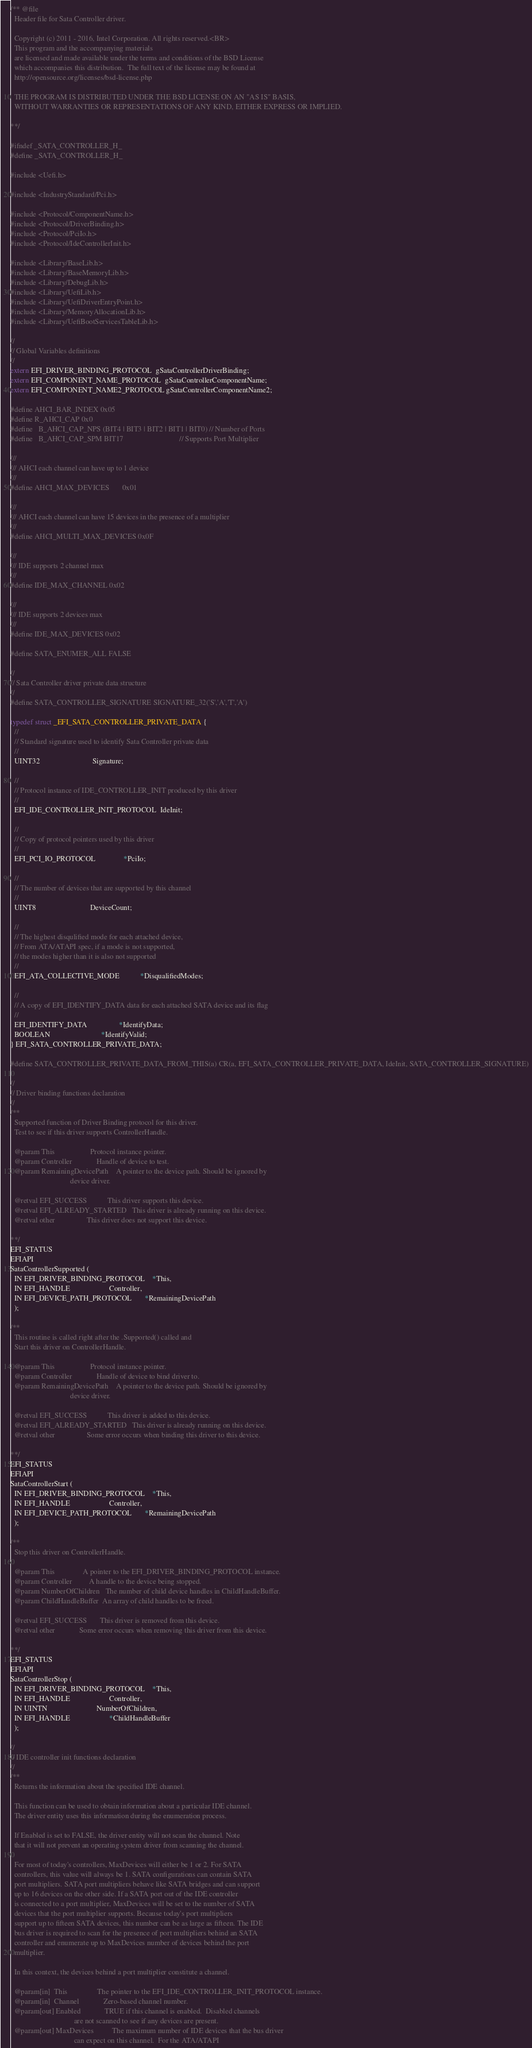<code> <loc_0><loc_0><loc_500><loc_500><_C_>/** @file
  Header file for Sata Controller driver.

  Copyright (c) 2011 - 2016, Intel Corporation. All rights reserved.<BR>
  This program and the accompanying materials
  are licensed and made available under the terms and conditions of the BSD License
  which accompanies this distribution.  The full text of the license may be found at
  http://opensource.org/licenses/bsd-license.php

  THE PROGRAM IS DISTRIBUTED UNDER THE BSD LICENSE ON AN "AS IS" BASIS,
  WITHOUT WARRANTIES OR REPRESENTATIONS OF ANY KIND, EITHER EXPRESS OR IMPLIED.

**/

#ifndef _SATA_CONTROLLER_H_
#define _SATA_CONTROLLER_H_

#include <Uefi.h>

#include <IndustryStandard/Pci.h>

#include <Protocol/ComponentName.h>
#include <Protocol/DriverBinding.h>
#include <Protocol/PciIo.h>
#include <Protocol/IdeControllerInit.h>

#include <Library/BaseLib.h>
#include <Library/BaseMemoryLib.h>
#include <Library/DebugLib.h>
#include <Library/UefiLib.h>
#include <Library/UefiDriverEntryPoint.h>
#include <Library/MemoryAllocationLib.h>
#include <Library/UefiBootServicesTableLib.h>

//
// Global Variables definitions
//
extern EFI_DRIVER_BINDING_PROTOCOL  gSataControllerDriverBinding;
extern EFI_COMPONENT_NAME_PROTOCOL  gSataControllerComponentName;
extern EFI_COMPONENT_NAME2_PROTOCOL gSataControllerComponentName2;

#define AHCI_BAR_INDEX 0x05
#define R_AHCI_CAP 0x0
#define   B_AHCI_CAP_NPS (BIT4 | BIT3 | BIT2 | BIT1 | BIT0) // Number of Ports
#define   B_AHCI_CAP_SPM BIT17                              // Supports Port Multiplier

///
/// AHCI each channel can have up to 1 device
///
#define AHCI_MAX_DEVICES       0x01

///
/// AHCI each channel can have 15 devices in the presence of a multiplier
///
#define AHCI_MULTI_MAX_DEVICES 0x0F

///
/// IDE supports 2 channel max
///
#define IDE_MAX_CHANNEL 0x02

///
/// IDE supports 2 devices max
///
#define IDE_MAX_DEVICES 0x02

#define SATA_ENUMER_ALL FALSE

//
// Sata Controller driver private data structure
//
#define SATA_CONTROLLER_SIGNATURE SIGNATURE_32('S','A','T','A')

typedef struct _EFI_SATA_CONTROLLER_PRIVATE_DATA {
  //
  // Standard signature used to identify Sata Controller private data
  //
  UINT32                            Signature;

  //
  // Protocol instance of IDE_CONTROLLER_INIT produced by this driver
  //
  EFI_IDE_CONTROLLER_INIT_PROTOCOL  IdeInit;

  //
  // Copy of protocol pointers used by this driver
  //
  EFI_PCI_IO_PROTOCOL               *PciIo;

  //
  // The number of devices that are supported by this channel
  //
  UINT8                             DeviceCount;

  //
  // The highest disqulified mode for each attached device,
  // From ATA/ATAPI spec, if a mode is not supported,
  // the modes higher than it is also not supported
  //
  EFI_ATA_COLLECTIVE_MODE           *DisqualifiedModes;

  //
  // A copy of EFI_IDENTIFY_DATA data for each attached SATA device and its flag
  //
  EFI_IDENTIFY_DATA                 *IdentifyData;
  BOOLEAN                           *IdentifyValid;
} EFI_SATA_CONTROLLER_PRIVATE_DATA;

#define SATA_CONTROLLER_PRIVATE_DATA_FROM_THIS(a) CR(a, EFI_SATA_CONTROLLER_PRIVATE_DATA, IdeInit, SATA_CONTROLLER_SIGNATURE)

//
// Driver binding functions declaration
//
/**
  Supported function of Driver Binding protocol for this driver.
  Test to see if this driver supports ControllerHandle.

  @param This                   Protocol instance pointer.
  @param Controller             Handle of device to test.
  @param RemainingDevicePath    A pointer to the device path. Should be ignored by
                                device driver.

  @retval EFI_SUCCESS           This driver supports this device.
  @retval EFI_ALREADY_STARTED   This driver is already running on this device.
  @retval other                 This driver does not support this device.

**/
EFI_STATUS
EFIAPI
SataControllerSupported (
  IN EFI_DRIVER_BINDING_PROTOCOL    *This,
  IN EFI_HANDLE                     Controller,
  IN EFI_DEVICE_PATH_PROTOCOL       *RemainingDevicePath
  );

/**
  This routine is called right after the .Supported() called and 
  Start this driver on ControllerHandle.

  @param This                   Protocol instance pointer.
  @param Controller             Handle of device to bind driver to.
  @param RemainingDevicePath    A pointer to the device path. Should be ignored by
                                device driver.

  @retval EFI_SUCCESS           This driver is added to this device.
  @retval EFI_ALREADY_STARTED   This driver is already running on this device.
  @retval other                 Some error occurs when binding this driver to this device.

**/
EFI_STATUS
EFIAPI
SataControllerStart (
  IN EFI_DRIVER_BINDING_PROTOCOL    *This,
  IN EFI_HANDLE                     Controller,
  IN EFI_DEVICE_PATH_PROTOCOL       *RemainingDevicePath
  );

/**
  Stop this driver on ControllerHandle.

  @param This               A pointer to the EFI_DRIVER_BINDING_PROTOCOL instance.
  @param Controller         A handle to the device being stopped.
  @param NumberOfChildren   The number of child device handles in ChildHandleBuffer.
  @param ChildHandleBuffer  An array of child handles to be freed. 

  @retval EFI_SUCCESS       This driver is removed from this device.
  @retval other             Some error occurs when removing this driver from this device.

**/
EFI_STATUS
EFIAPI
SataControllerStop (
  IN EFI_DRIVER_BINDING_PROTOCOL    *This,
  IN EFI_HANDLE                     Controller,
  IN UINTN                          NumberOfChildren,
  IN EFI_HANDLE                     *ChildHandleBuffer
  );

//
// IDE controller init functions declaration
//
/**
  Returns the information about the specified IDE channel.
  
  This function can be used to obtain information about a particular IDE channel.
  The driver entity uses this information during the enumeration process. 
  
  If Enabled is set to FALSE, the driver entity will not scan the channel. Note 
  that it will not prevent an operating system driver from scanning the channel.
  
  For most of today's controllers, MaxDevices will either be 1 or 2. For SATA 
  controllers, this value will always be 1. SATA configurations can contain SATA 
  port multipliers. SATA port multipliers behave like SATA bridges and can support
  up to 16 devices on the other side. If a SATA port out of the IDE controller 
  is connected to a port multiplier, MaxDevices will be set to the number of SATA 
  devices that the port multiplier supports. Because today's port multipliers 
  support up to fifteen SATA devices, this number can be as large as fifteen. The IDE  
  bus driver is required to scan for the presence of port multipliers behind an SATA 
  controller and enumerate up to MaxDevices number of devices behind the port 
  multiplier.    
  
  In this context, the devices behind a port multiplier constitute a channel.  
  
  @param[in]  This                The pointer to the EFI_IDE_CONTROLLER_INIT_PROTOCOL instance.
  @param[in]  Channel             Zero-based channel number.
  @param[out] Enabled             TRUE if this channel is enabled.  Disabled channels 
                                  are not scanned to see if any devices are present.
  @param[out] MaxDevices          The maximum number of IDE devices that the bus driver
                                  can expect on this channel.  For the ATA/ATAPI </code> 